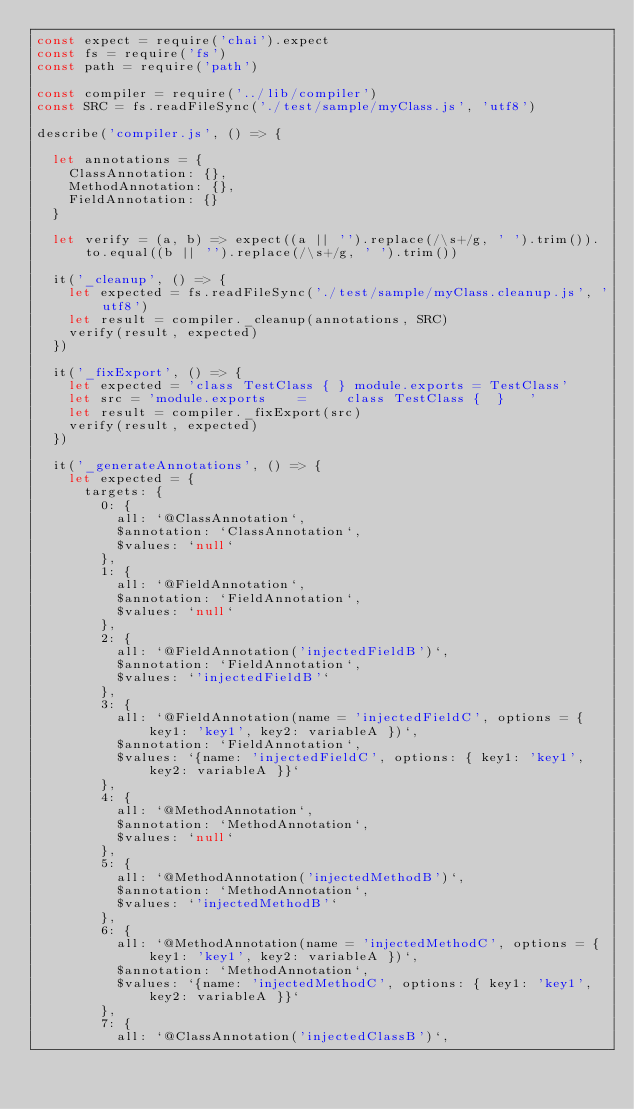Convert code to text. <code><loc_0><loc_0><loc_500><loc_500><_JavaScript_>const expect = require('chai').expect
const fs = require('fs')
const path = require('path')

const compiler = require('../lib/compiler')
const SRC = fs.readFileSync('./test/sample/myClass.js', 'utf8')

describe('compiler.js', () => {

  let annotations = {
    ClassAnnotation: {},
    MethodAnnotation: {},
    FieldAnnotation: {}
  }

  let verify = (a, b) => expect((a || '').replace(/\s+/g, ' ').trim()).to.equal((b || '').replace(/\s+/g, ' ').trim())

  it('_cleanup', () => {
    let expected = fs.readFileSync('./test/sample/myClass.cleanup.js', 'utf8')
    let result = compiler._cleanup(annotations, SRC)
    verify(result, expected)
  })

  it('_fixExport', () => {
    let expected = 'class TestClass { } module.exports = TestClass'
    let src = 'module.exports    =     class TestClass {  }   '
    let result = compiler._fixExport(src)
    verify(result, expected)
  })

  it('_generateAnnotations', () => {
    let expected = {
      targets: {
        0: {
          all: `@ClassAnnotation`,
          $annotation: `ClassAnnotation`,
          $values: `null`
        },
        1: {
          all: `@FieldAnnotation`,
          $annotation: `FieldAnnotation`,
          $values: `null`
        },
        2: {
          all: `@FieldAnnotation('injectedFieldB')`,
          $annotation: `FieldAnnotation`,
          $values: `'injectedFieldB'`
        },
        3: {
          all: `@FieldAnnotation(name = 'injectedFieldC', options = { key1: 'key1', key2: variableA })`,
          $annotation: `FieldAnnotation`,
          $values: `{name: 'injectedFieldC', options: { key1: 'key1', key2: variableA }}`
        },
        4: {
          all: `@MethodAnnotation`,
          $annotation: `MethodAnnotation`,
          $values: `null`
        },
        5: {
          all: `@MethodAnnotation('injectedMethodB')`,
          $annotation: `MethodAnnotation`,
          $values: `'injectedMethodB'`
        },
        6: {
          all: `@MethodAnnotation(name = 'injectedMethodC', options = { key1: 'key1', key2: variableA })`,
          $annotation: `MethodAnnotation`,
          $values: `{name: 'injectedMethodC', options: { key1: 'key1', key2: variableA }}`
        },
        7: {
          all: `@ClassAnnotation('injectedClassB')`,</code> 